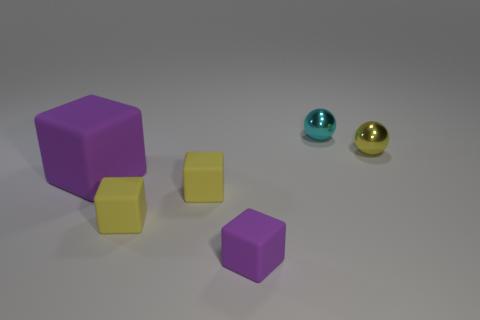Subtract all tiny matte blocks. How many blocks are left? 1 Subtract all yellow spheres. How many purple blocks are left? 2 Add 3 yellow rubber cubes. How many objects exist? 9 Subtract all cyan spheres. How many spheres are left? 1 Subtract all balls. How many objects are left? 4 Subtract 1 spheres. How many spheres are left? 1 Subtract all balls. Subtract all large red cubes. How many objects are left? 4 Add 3 small metal balls. How many small metal balls are left? 5 Add 3 purple matte cylinders. How many purple matte cylinders exist? 3 Subtract 1 yellow spheres. How many objects are left? 5 